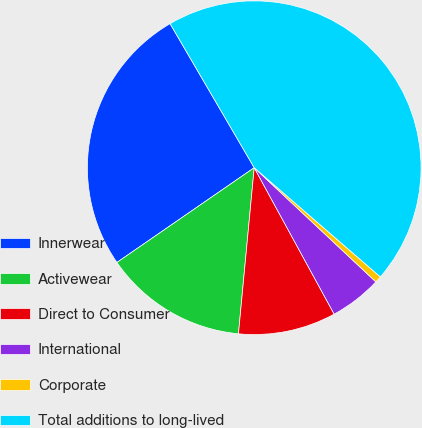Convert chart. <chart><loc_0><loc_0><loc_500><loc_500><pie_chart><fcel>Innerwear<fcel>Activewear<fcel>Direct to Consumer<fcel>International<fcel>Corporate<fcel>Total additions to long-lived<nl><fcel>26.2%<fcel>13.88%<fcel>9.46%<fcel>5.05%<fcel>0.64%<fcel>44.77%<nl></chart> 